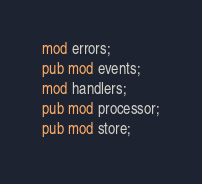Convert code to text. <code><loc_0><loc_0><loc_500><loc_500><_Rust_>mod errors;
pub mod events;
mod handlers;
pub mod processor;
pub mod store;
</code> 